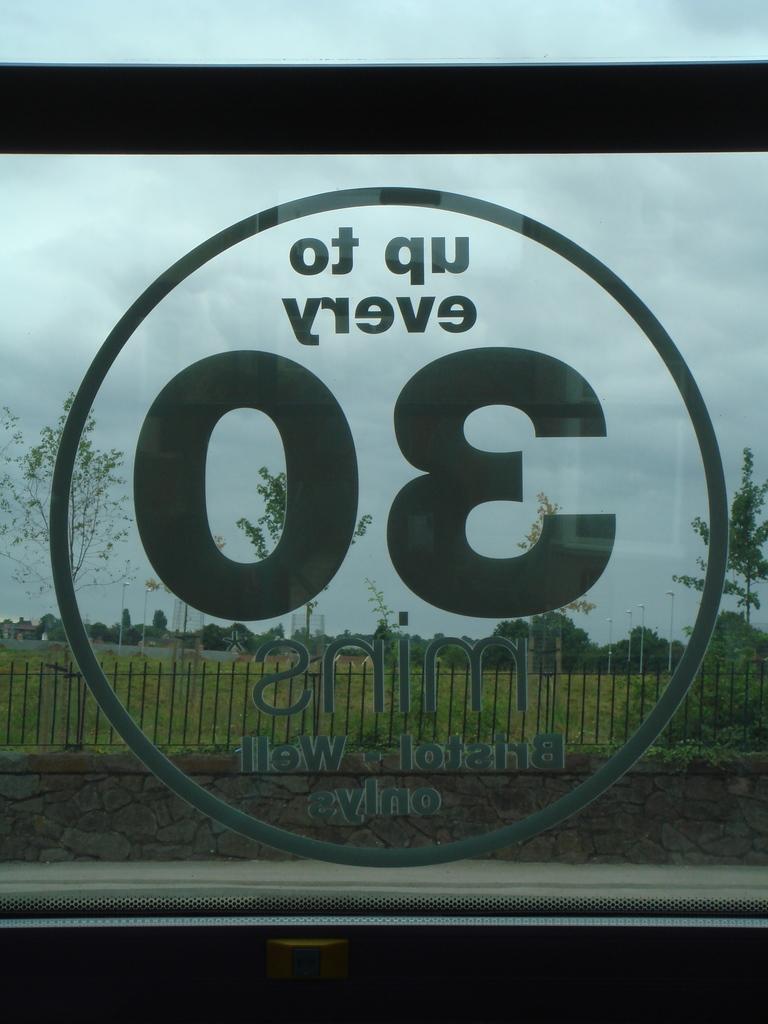In one or two sentences, can you explain what this image depicts? In this picture I can see a sticker on the window of a vehicle, and in the background there is a wall, iron grills, lights, poles, trees and sky. 